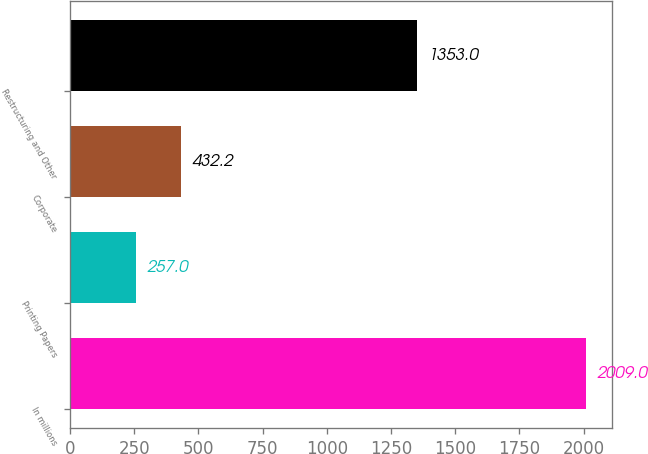Convert chart. <chart><loc_0><loc_0><loc_500><loc_500><bar_chart><fcel>In millions<fcel>Printing Papers<fcel>Corporate<fcel>Restructuring and Other<nl><fcel>2009<fcel>257<fcel>432.2<fcel>1353<nl></chart> 